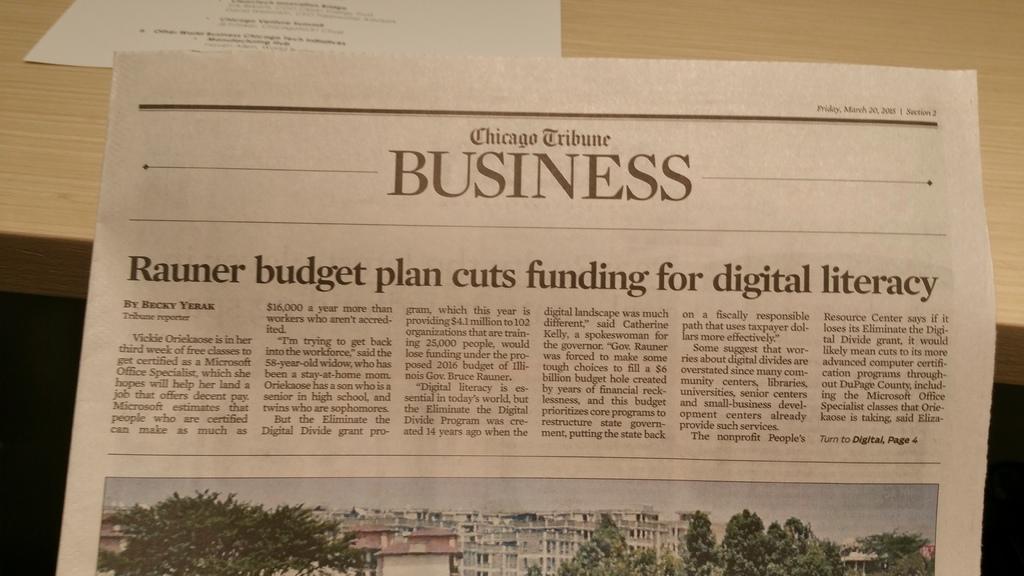Which section of the newspaper is displayed?
Provide a succinct answer. Business. What is the title of the article?
Your answer should be very brief. Rauner budget plan cuts funding for digital literacy. 